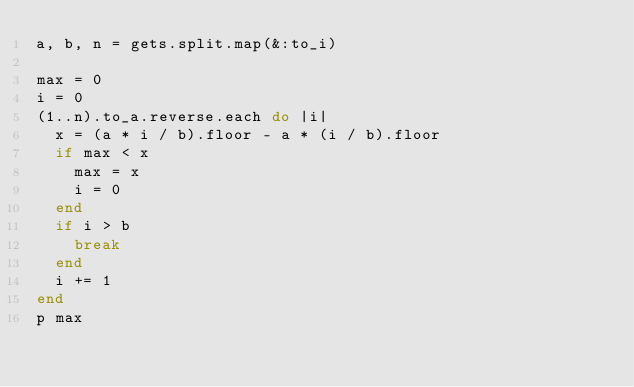<code> <loc_0><loc_0><loc_500><loc_500><_Ruby_>a, b, n = gets.split.map(&:to_i)

max = 0
i = 0
(1..n).to_a.reverse.each do |i|
  x = (a * i / b).floor - a * (i / b).floor
  if max < x
    max = x
    i = 0
  end
  if i > b
    break
  end
  i += 1
end
p max</code> 